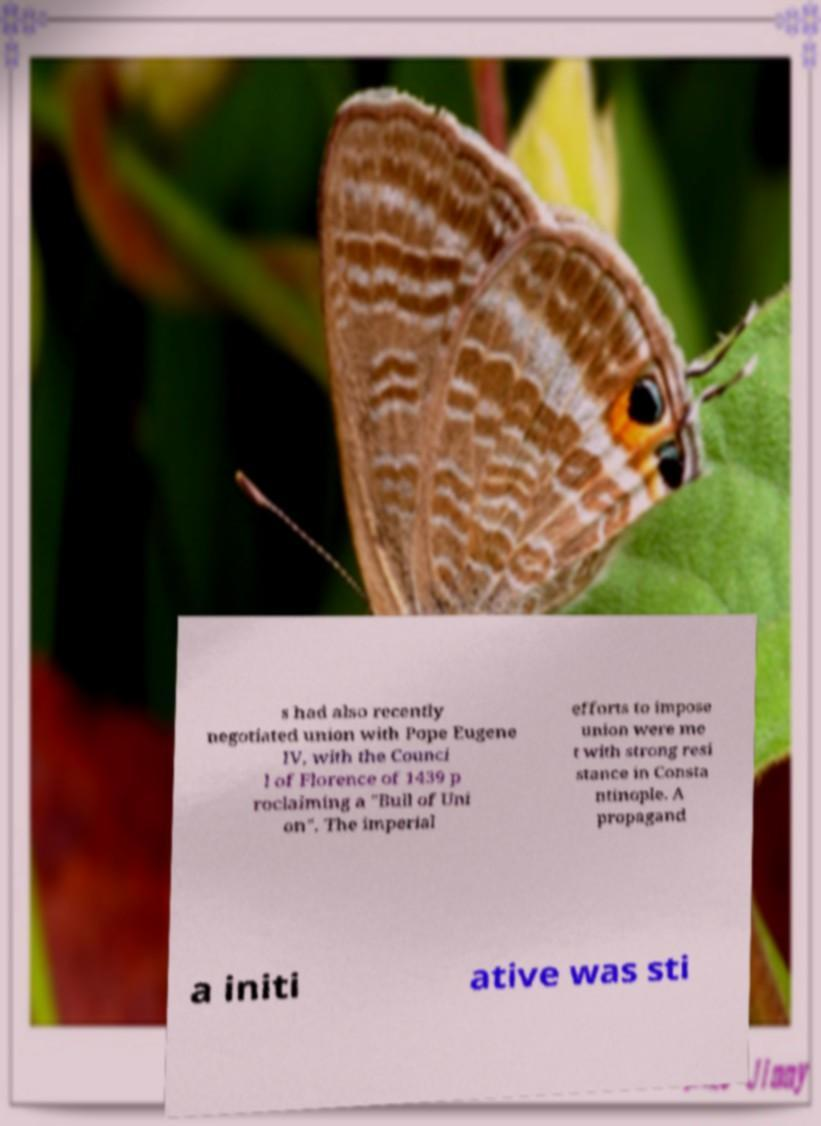Can you read and provide the text displayed in the image?This photo seems to have some interesting text. Can you extract and type it out for me? s had also recently negotiated union with Pope Eugene IV, with the Counci l of Florence of 1439 p roclaiming a "Bull of Uni on". The imperial efforts to impose union were me t with strong resi stance in Consta ntinople. A propagand a initi ative was sti 